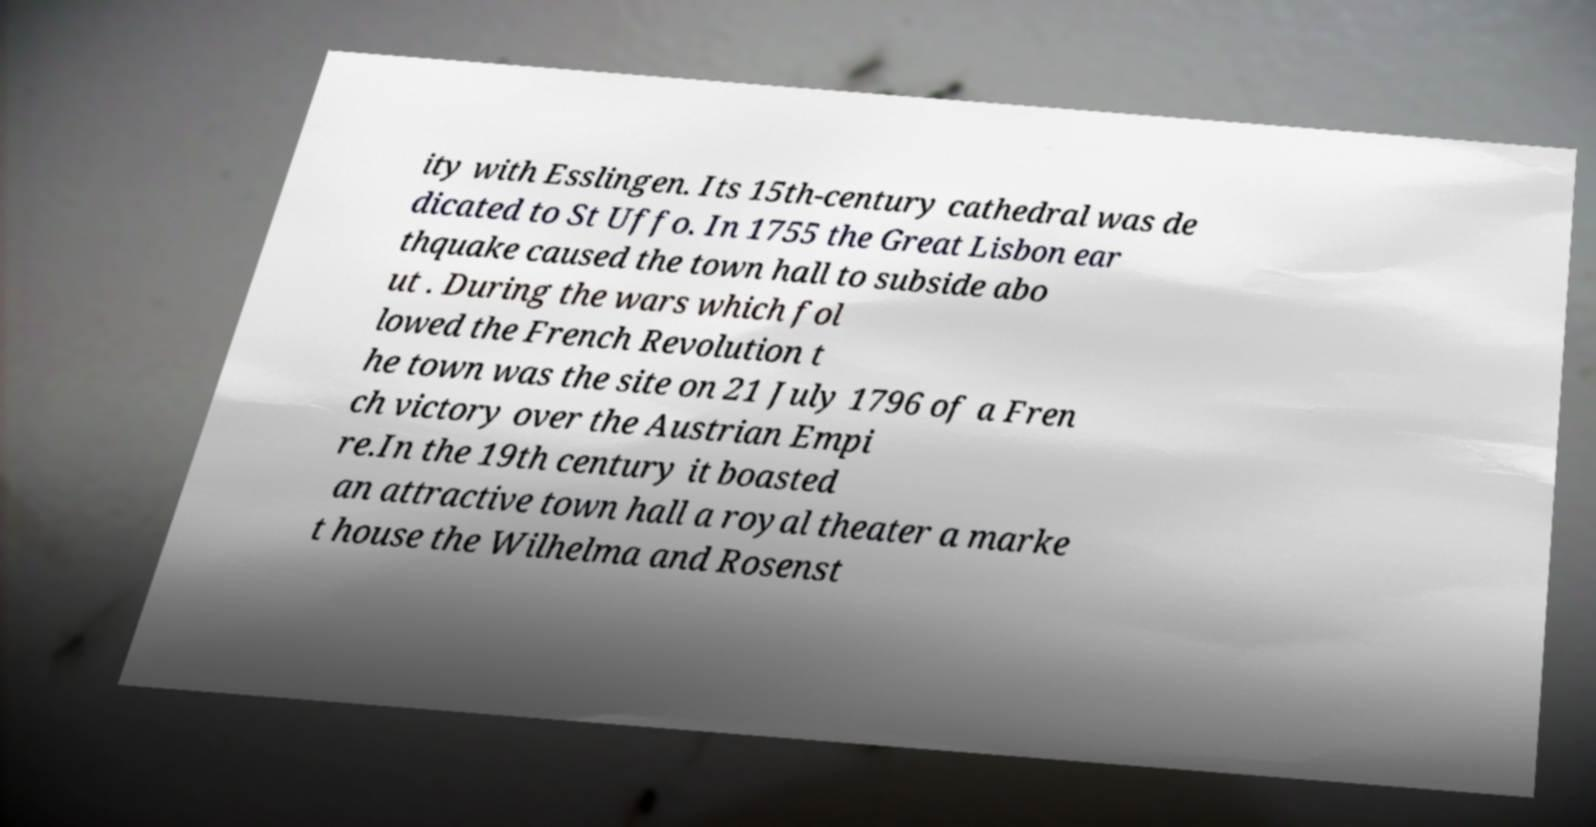What messages or text are displayed in this image? I need them in a readable, typed format. ity with Esslingen. Its 15th-century cathedral was de dicated to St Uffo. In 1755 the Great Lisbon ear thquake caused the town hall to subside abo ut . During the wars which fol lowed the French Revolution t he town was the site on 21 July 1796 of a Fren ch victory over the Austrian Empi re.In the 19th century it boasted an attractive town hall a royal theater a marke t house the Wilhelma and Rosenst 